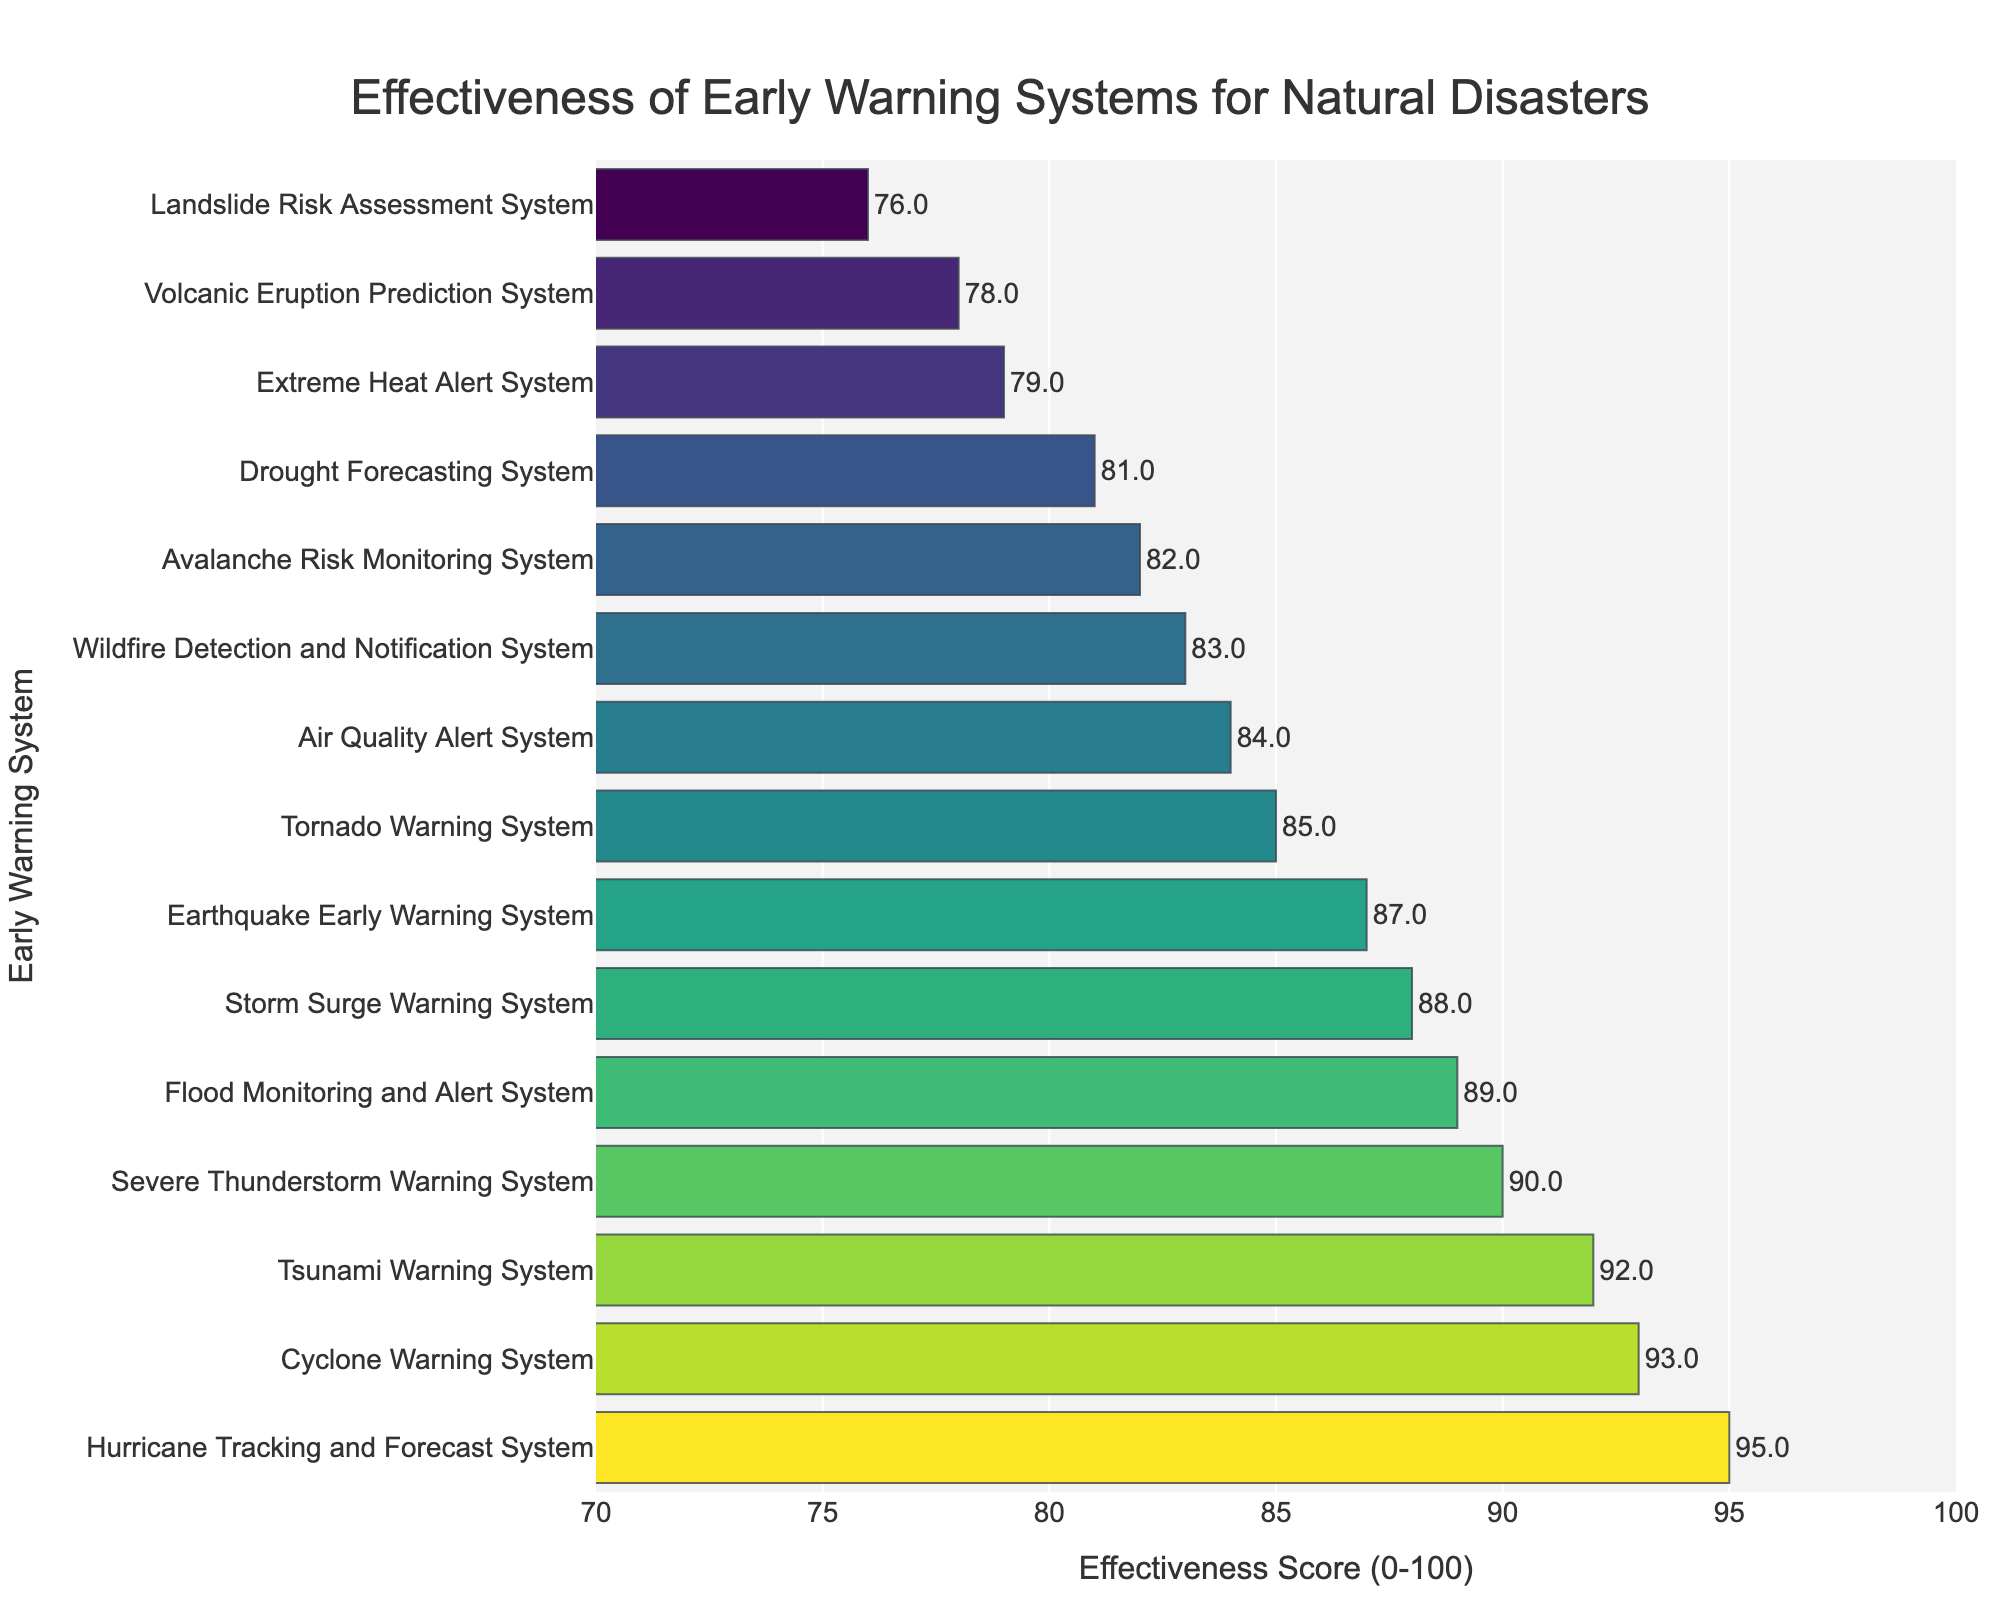Which early warning system is the most effective? The bar representing the Hurricane Tracking and Forecast System has the highest effectiveness score, so it is the most effective system.
Answer: Hurricane Tracking and Forecast System Which early warning system is the least effective? The bar representing the Landslide Risk Assessment System has the lowest effectiveness score, making it the least effective system.
Answer: Landslide Risk Assessment System How much more effective is the Tsunami Warning System compared to the Earthquake Early Warning System? The effectiveness scores of Tsunami Warning System and Earthquake Early Warning System are 92 and 87 respectively. The difference is 92 - 87 = 5.
Answer: 5 What is the average effectiveness score of all the early warning systems? Add up all the effectiveness scores and divide by the number of systems: (87 + 92 + 95 + 89 + 83 + 78 + 85 + 76 + 81 + 79 + 88 + 82 + 84 + 90 + 93) / 15 = 1282 / 15 ≈ 85.47
Answer: 85.47 Which systems have effectiveness scores greater than 90? The bars representing Hurricane Tracking and Forecast System, Tsunami Warning System, and Cyclone Warning System have scores above 90.
Answer: Hurricane Tracking and Forecast System, Tsunami Warning System, Cyclone Warning System Which system has an effectiveness score of 88? The bar representing the Storm Surge Warning System shows an effectiveness score of 88.
Answer: Storm Surge Warning System Is the Flood Monitoring and Alert System more effective than the Severe Thunderstorm Warning System? The Flood Monitoring and Alert System has an effectiveness score of 89, while the Severe Thunderstorm Warning System has a score of 90. Therefore, the Severe Thunderstorm Warning System is more effective.
Answer: No What is the combined effectiveness score of the Wildfire Detection and Notification System and the Drought Forecasting System? The effectiveness scores for the Wildfire Detection and Notification System and the Drought Forecasting System are 83 and 81 respectively. The combined score is 83 + 81 = 164.
Answer: 164 Which early warning systems have effectiveness scores between 80 and 85 inclusive? The bars representing Air Quality Alert System, Avalanche Risk Monitoring System, Drought Forecasting System, and Wildfire Detection and Notification System have scores in the range 80-85.
Answer: Air Quality Alert System, Avalanche Risk Monitoring System, Drought Forecasting System, Wildfire Detection and Notification System 